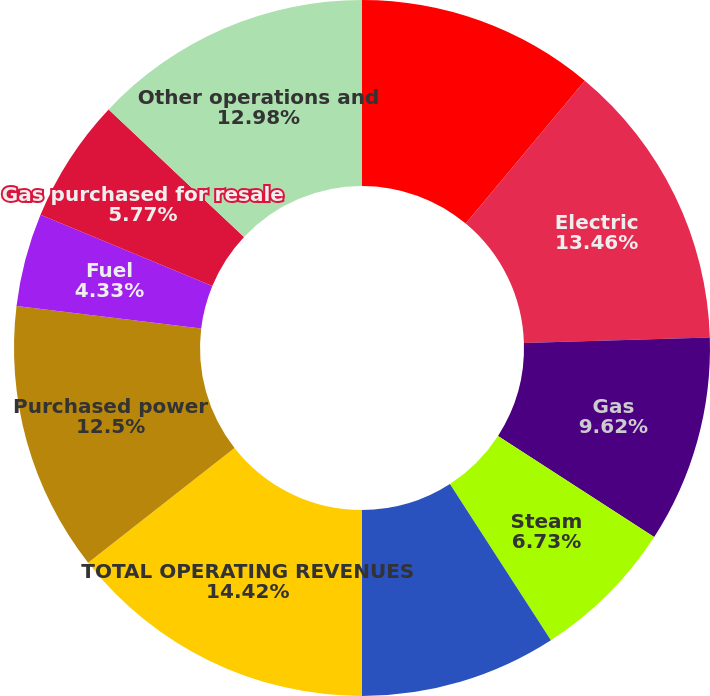Convert chart to OTSL. <chart><loc_0><loc_0><loc_500><loc_500><pie_chart><fcel>(Millions of Dollars/Except<fcel>Electric<fcel>Gas<fcel>Steam<fcel>Non-utility<fcel>TOTAL OPERATING REVENUES<fcel>Purchased power<fcel>Fuel<fcel>Gas purchased for resale<fcel>Other operations and<nl><fcel>11.06%<fcel>13.46%<fcel>9.62%<fcel>6.73%<fcel>9.13%<fcel>14.42%<fcel>12.5%<fcel>4.33%<fcel>5.77%<fcel>12.98%<nl></chart> 